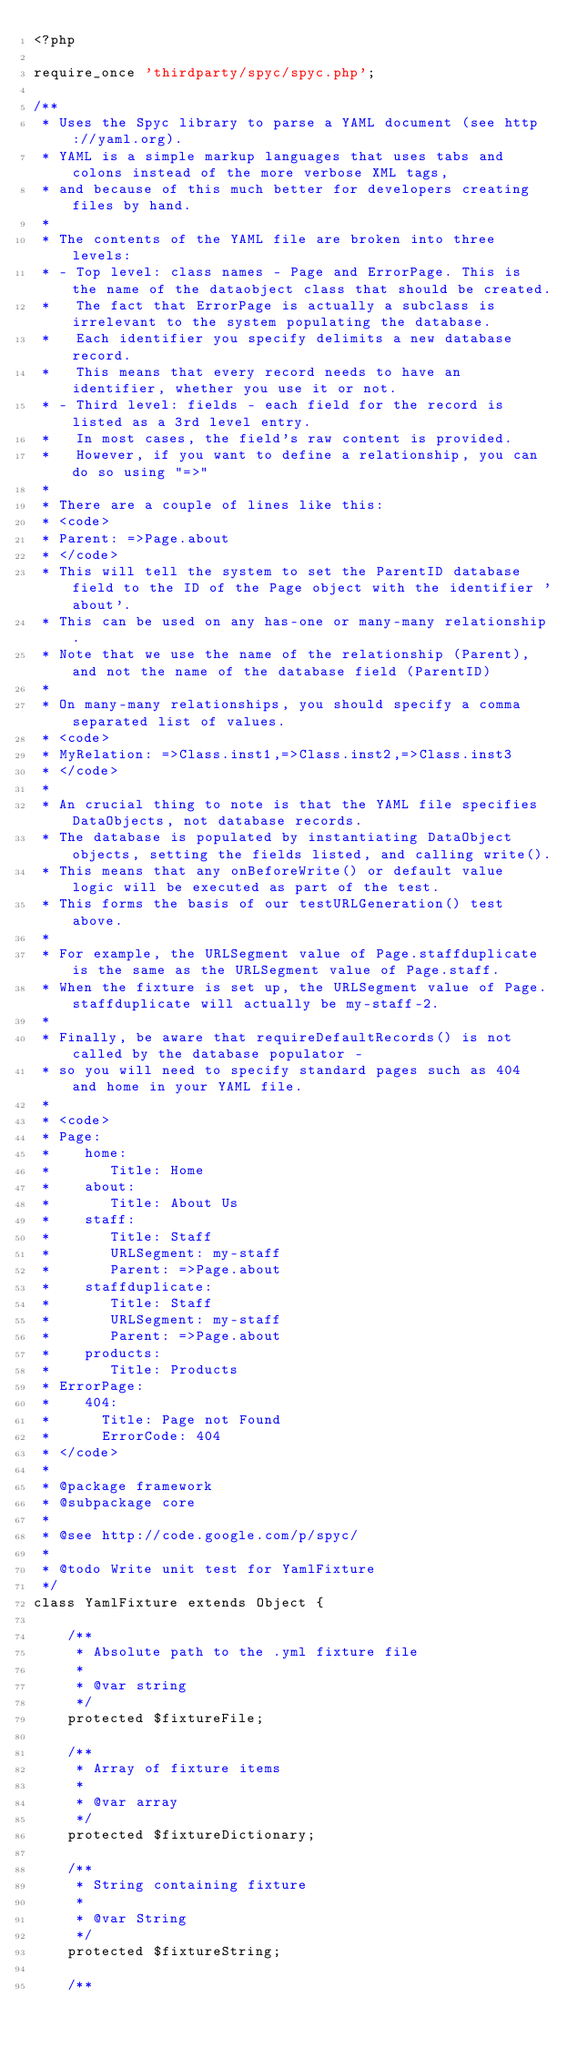<code> <loc_0><loc_0><loc_500><loc_500><_PHP_><?php

require_once 'thirdparty/spyc/spyc.php';

/**
 * Uses the Spyc library to parse a YAML document (see http://yaml.org).
 * YAML is a simple markup languages that uses tabs and colons instead of the more verbose XML tags, 
 * and because of this much better for developers creating files by hand.
 * 
 * The contents of the YAML file are broken into three levels:
 * - Top level: class names - Page and ErrorPage. This is the name of the dataobject class that should be created. 
 *   The fact that ErrorPage is actually a subclass is irrelevant to the system populating the database. 
 *   Each identifier you specify delimits a new database record. 
 *   This means that every record needs to have an identifier, whether you use it or not.
 * - Third level: fields - each field for the record is listed as a 3rd level entry. 
 *   In most cases, the field's raw content is provided. 
 *   However, if you want to define a relationship, you can do so using "=>"
 * 
 * There are a couple of lines like this:
 * <code>
 * Parent: =>Page.about
 * </code>
 * This will tell the system to set the ParentID database field to the ID of the Page object with the identifier 'about'. 
 * This can be used on any has-one or many-many relationship. 
 * Note that we use the name of the relationship (Parent), and not the name of the database field (ParentID)
 *
 * On many-many relationships, you should specify a comma separated list of values.
 * <code>
 * MyRelation: =>Class.inst1,=>Class.inst2,=>Class.inst3
 * </code>
 * 
 * An crucial thing to note is that the YAML file specifies DataObjects, not database records. 
 * The database is populated by instantiating DataObject objects, setting the fields listed, and calling write(). 
 * This means that any onBeforeWrite() or default value logic will be executed as part of the test. 
 * This forms the basis of our testURLGeneration() test above.
 * 
 * For example, the URLSegment value of Page.staffduplicate is the same as the URLSegment value of Page.staff. 
 * When the fixture is set up, the URLSegment value of Page.staffduplicate will actually be my-staff-2.
 * 
 * Finally, be aware that requireDefaultRecords() is not called by the database populator - 
 * so you will need to specify standard pages such as 404 and home in your YAML file.
 * 
 * <code>
 * Page:
 *    home:
 *       Title: Home
 *    about:
 *       Title: About Us
 *    staff:
 *       Title: Staff
 *       URLSegment: my-staff
 *       Parent: =>Page.about
 *    staffduplicate:
 *       Title: Staff
 *       URLSegment: my-staff
 *       Parent: =>Page.about
 *    products:
 *       Title: Products
 * ErrorPage:
 *    404:
 *      Title: Page not Found
 *      ErrorCode: 404
 * </code>
 * 
 * @package framework
 * @subpackage core
 * 
 * @see http://code.google.com/p/spyc/
 * 
 * @todo Write unit test for YamlFixture
 */
class YamlFixture extends Object {
	
	/**
	 * Absolute path to the .yml fixture file
	 *
	 * @var string
	 */
	protected $fixtureFile;

	/**
	 * Array of fixture items
	 * 
	 * @var array
	 */
	protected $fixtureDictionary;

	/**
	 * String containing fixture
	 *
	 * @var String
	 */
	protected $fixtureString;

	/**</code> 